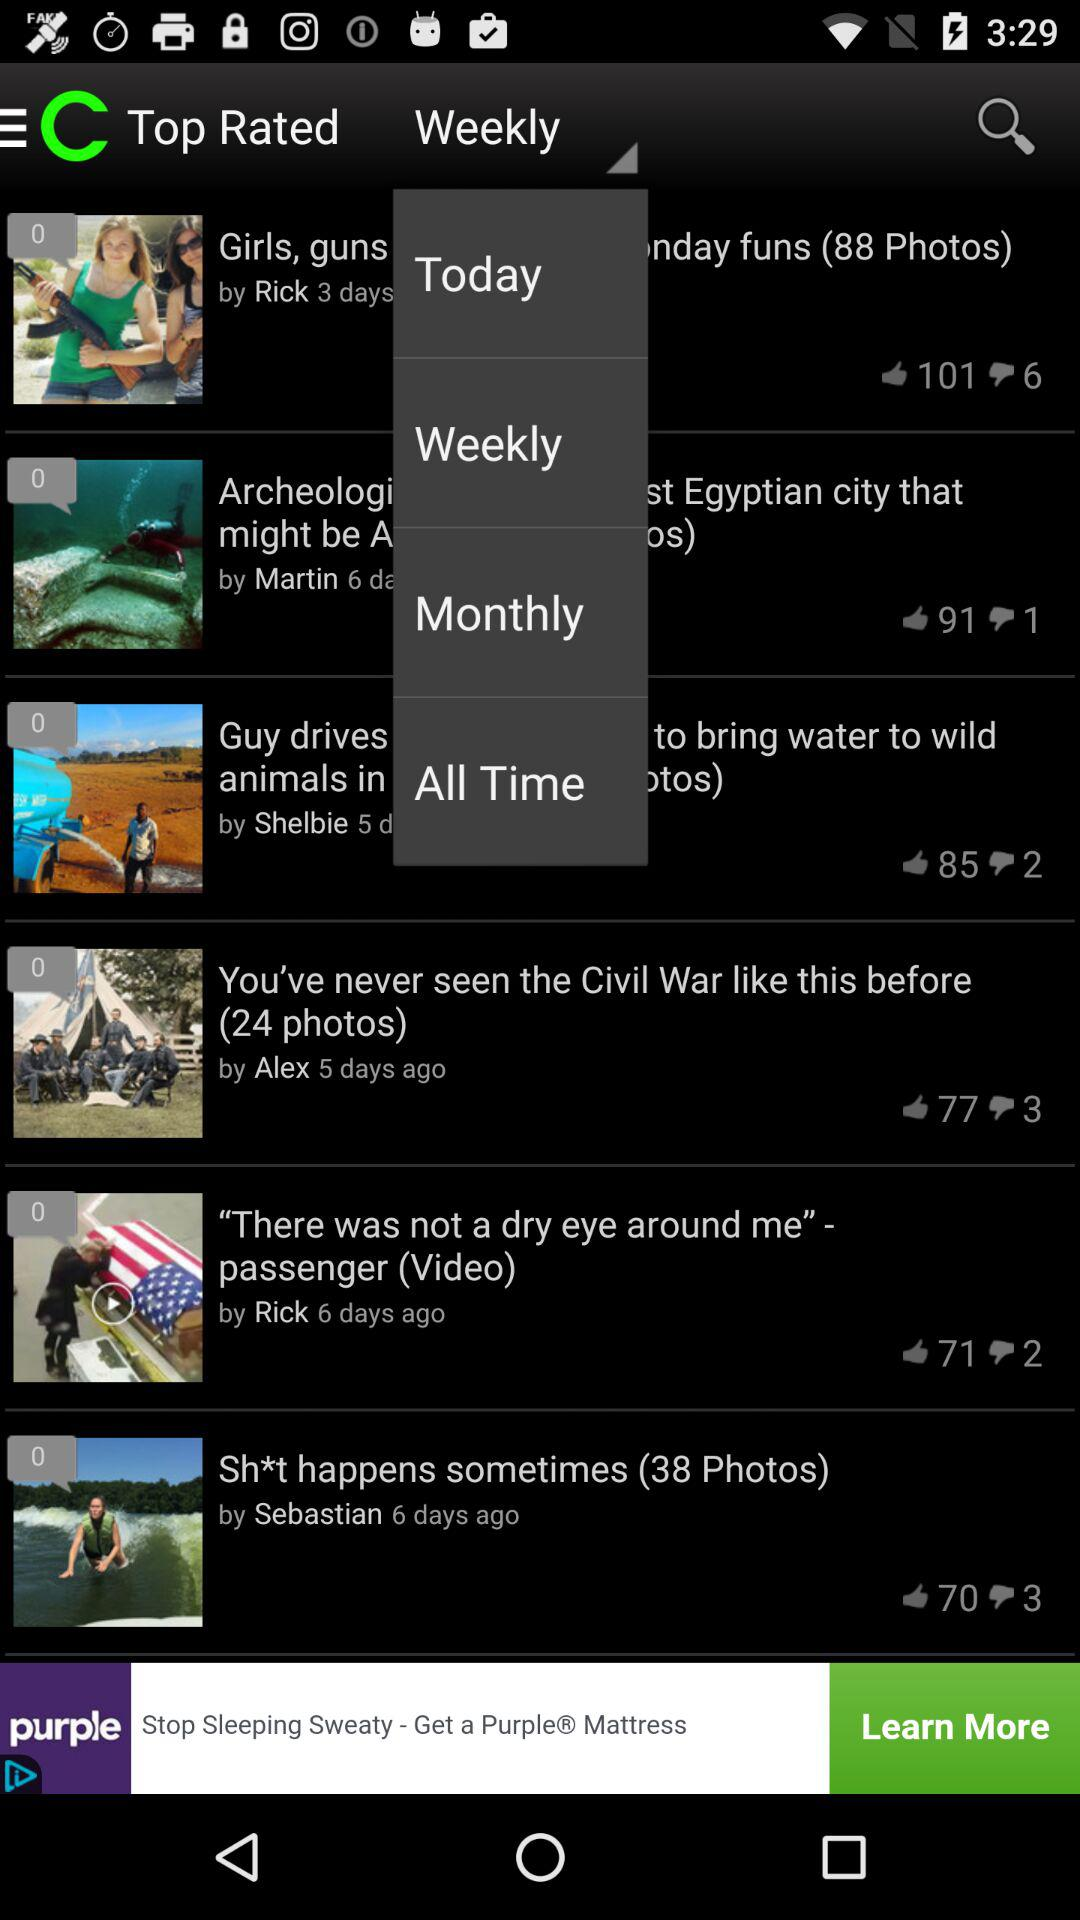How many thumbs down does the photo with the man riding a wave on a surfboard have?
Answer the question using a single word or phrase. 3 